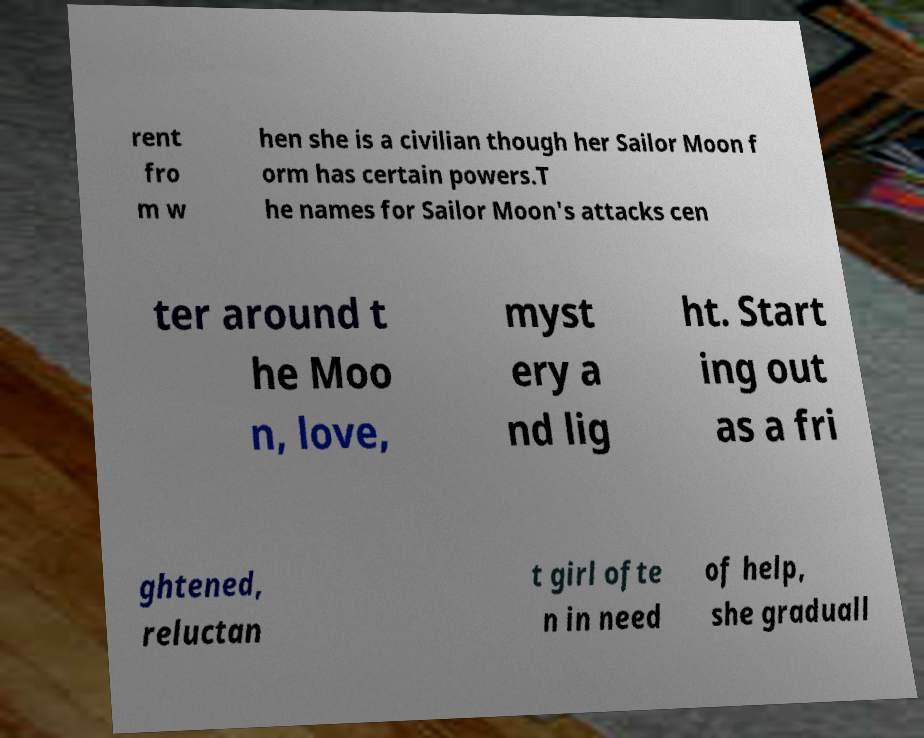What messages or text are displayed in this image? I need them in a readable, typed format. rent fro m w hen she is a civilian though her Sailor Moon f orm has certain powers.T he names for Sailor Moon's attacks cen ter around t he Moo n, love, myst ery a nd lig ht. Start ing out as a fri ghtened, reluctan t girl ofte n in need of help, she graduall 